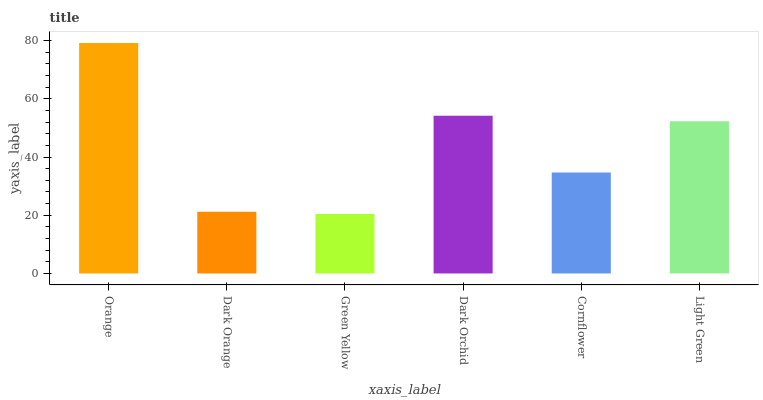Is Green Yellow the minimum?
Answer yes or no. Yes. Is Orange the maximum?
Answer yes or no. Yes. Is Dark Orange the minimum?
Answer yes or no. No. Is Dark Orange the maximum?
Answer yes or no. No. Is Orange greater than Dark Orange?
Answer yes or no. Yes. Is Dark Orange less than Orange?
Answer yes or no. Yes. Is Dark Orange greater than Orange?
Answer yes or no. No. Is Orange less than Dark Orange?
Answer yes or no. No. Is Light Green the high median?
Answer yes or no. Yes. Is Cornflower the low median?
Answer yes or no. Yes. Is Cornflower the high median?
Answer yes or no. No. Is Green Yellow the low median?
Answer yes or no. No. 